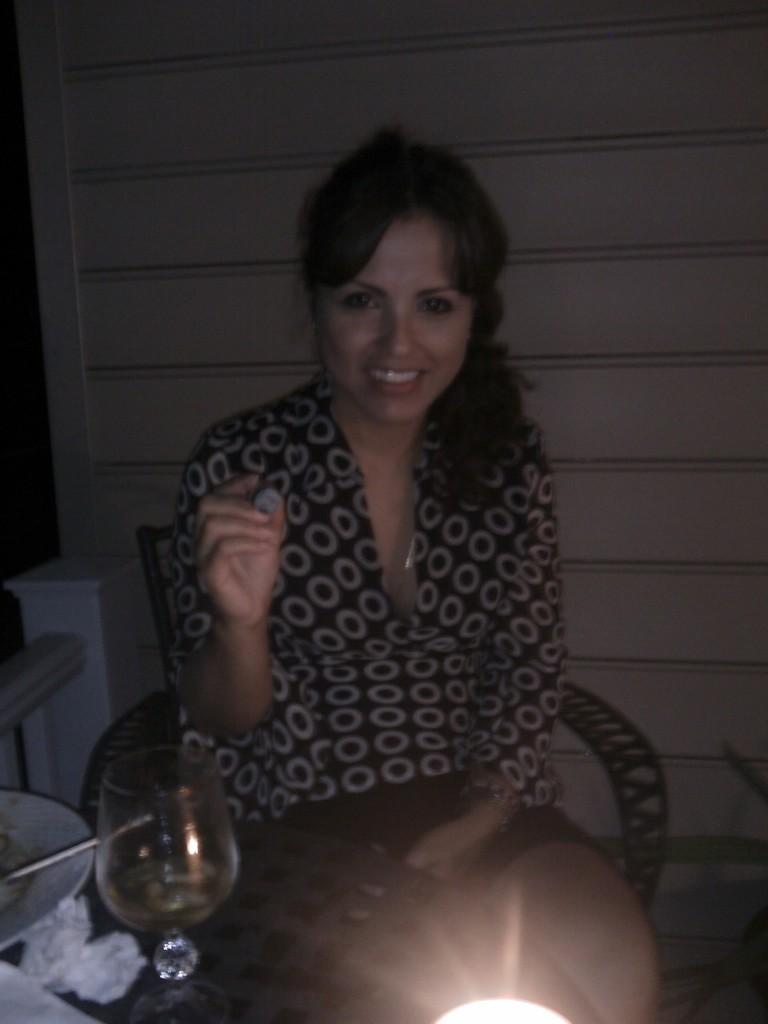Could you give a brief overview of what you see in this image? In this image there is a woman sitting on chair, in front of her there is a table, on that table there is a glass and a plate, in the background there is a wall. 